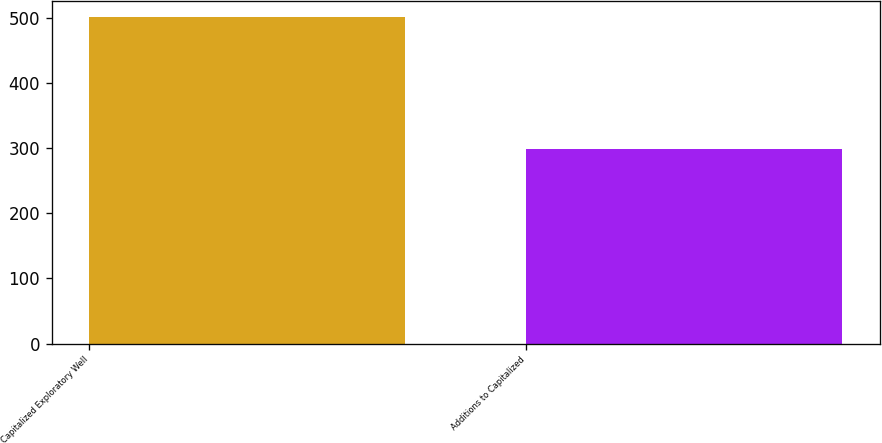Convert chart to OTSL. <chart><loc_0><loc_0><loc_500><loc_500><bar_chart><fcel>Capitalized Exploratory Well<fcel>Additions to Capitalized<nl><fcel>501<fcel>299<nl></chart> 